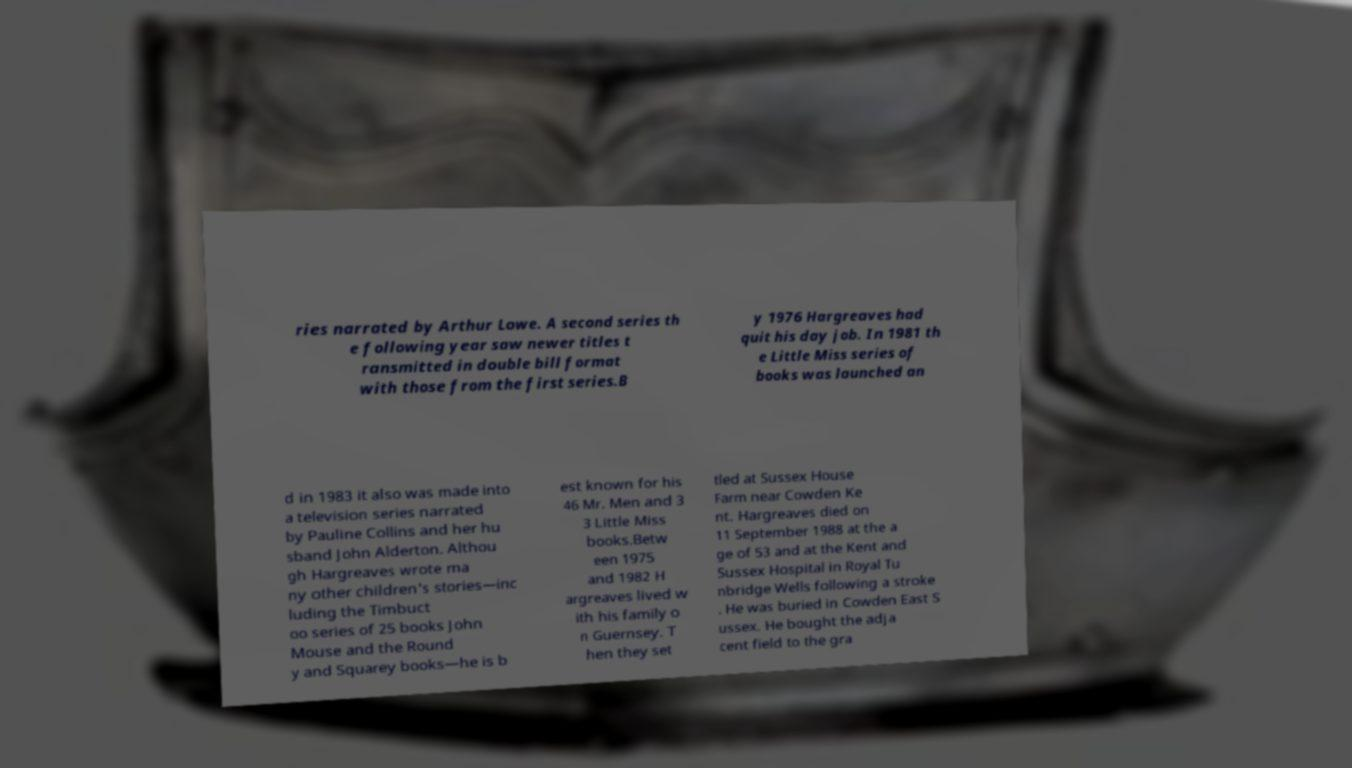Please identify and transcribe the text found in this image. ries narrated by Arthur Lowe. A second series th e following year saw newer titles t ransmitted in double bill format with those from the first series.B y 1976 Hargreaves had quit his day job. In 1981 th e Little Miss series of books was launched an d in 1983 it also was made into a television series narrated by Pauline Collins and her hu sband John Alderton. Althou gh Hargreaves wrote ma ny other children's stories—inc luding the Timbuct oo series of 25 books John Mouse and the Round y and Squarey books—he is b est known for his 46 Mr. Men and 3 3 Little Miss books.Betw een 1975 and 1982 H argreaves lived w ith his family o n Guernsey. T hen they set tled at Sussex House Farm near Cowden Ke nt. Hargreaves died on 11 September 1988 at the a ge of 53 and at the Kent and Sussex Hospital in Royal Tu nbridge Wells following a stroke . He was buried in Cowden East S ussex. He bought the adja cent field to the gra 